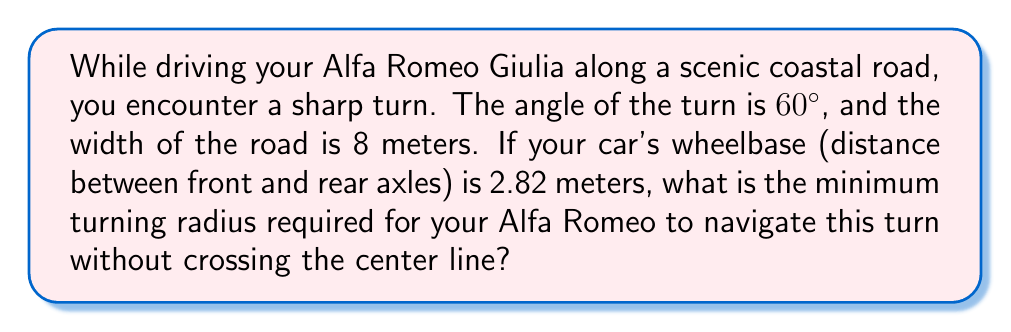Could you help me with this problem? Let's approach this step-by-step:

1) First, we need to understand that the minimum turning radius occurs when the outer front wheel follows the outer edge of the road, while the inner rear wheel follows the center line.

2) We can visualize this as a right triangle, where:
   - The hypotenuse is the turning radius (R)
   - One side is half the width of the road (4 meters)
   - The other side is the difference between the turning radius and the wheelbase (R - 2.82)

3) We can express this relationship using the tangent function:

   $$\tan(30°) = \frac{4}{R - 2.82}$$

   Note: We use 30° because it's half of the 60° turn angle.

4) We know that $\tan(30°) = \frac{1}{\sqrt{3}}$, so we can rewrite the equation:

   $$\frac{1}{\sqrt{3}} = \frac{4}{R - 2.82}$$

5) Cross-multiply:

   $$R - 2.82 = 4\sqrt{3}$$

6) Solve for R:

   $$R = 4\sqrt{3} + 2.82$$

7) Calculate the final value:

   $$R \approx 6.93 + 2.82 = 9.75$$ meters

Therefore, the minimum turning radius required is approximately 9.75 meters.
Answer: $9.75$ meters 